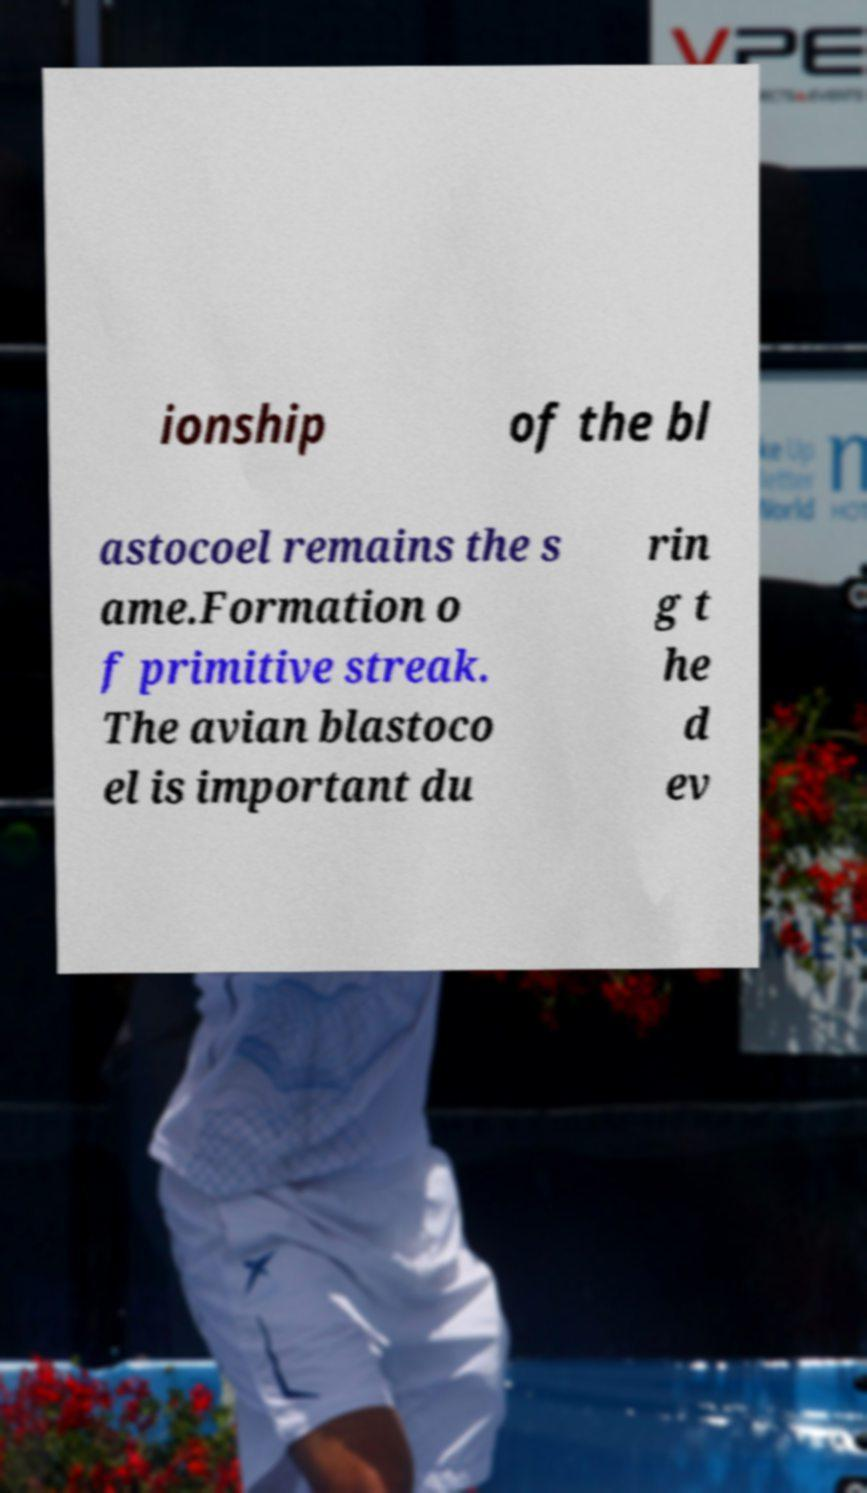Can you read and provide the text displayed in the image?This photo seems to have some interesting text. Can you extract and type it out for me? ionship of the bl astocoel remains the s ame.Formation o f primitive streak. The avian blastoco el is important du rin g t he d ev 